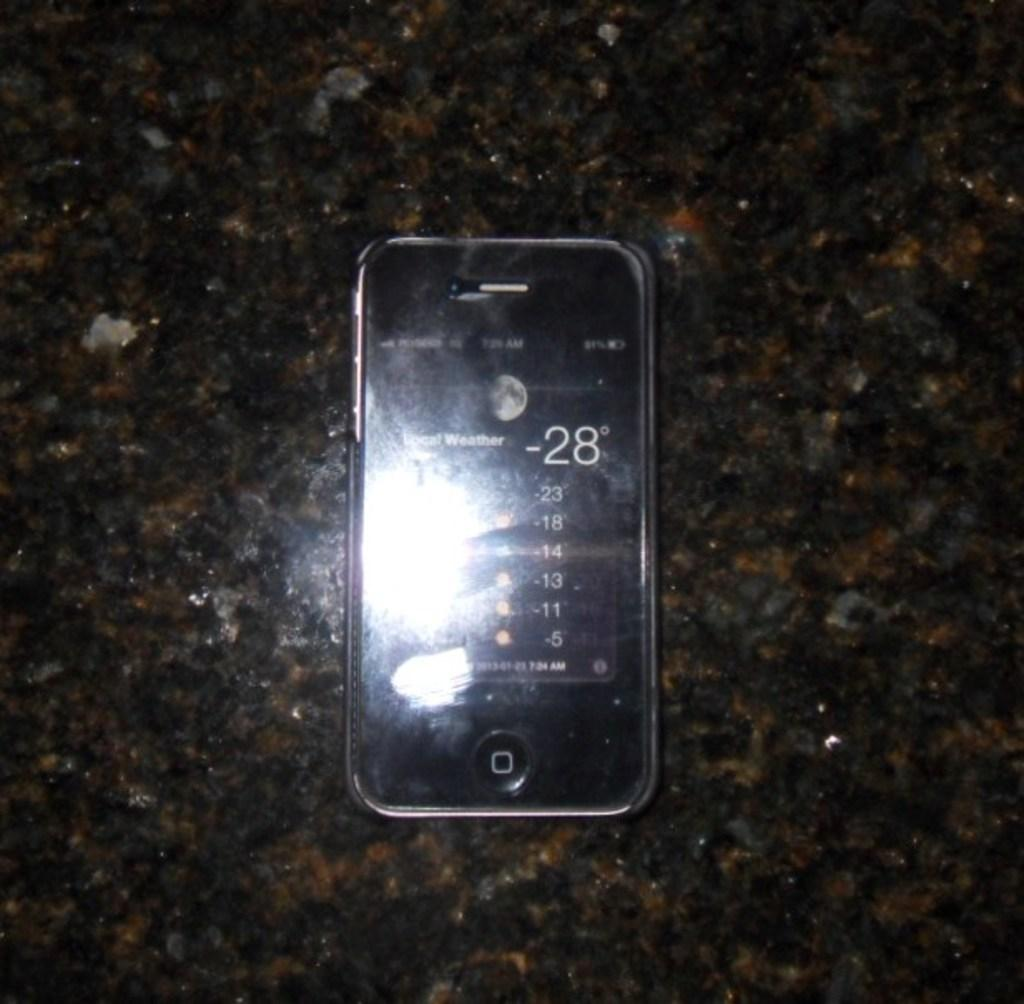What can be seen hanging in the image? There is a mobile in the image. What is the color of the surface beneath the mobile? The surface beneath the mobile is black, brown, and ash in color. What degree does the family member hold in the image? There is no family member or degree mentioned in the image. 